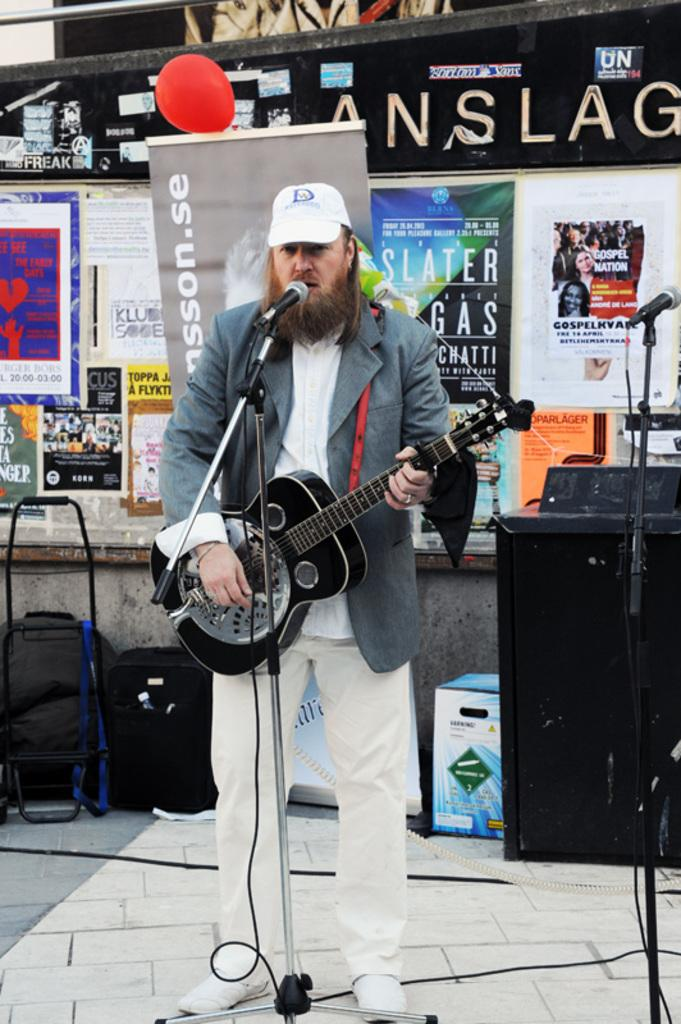What is the person in the image doing? The person is standing in the image and holding a guitar. What object is in front of the person? There is a microphone in front of the person. What can be seen in the background of the image? There is a balloon, a banner, and posters in the background of the image. What type of school can be seen in the background of the image? There is no school present in the image; it features a person holding a guitar, a microphone, and various items in the background. 